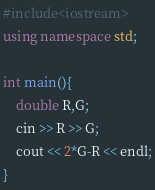Convert code to text. <code><loc_0><loc_0><loc_500><loc_500><_C++_>#include<iostream>
using namespace std;

int main(){
	double R,G;
	cin >> R >> G;
	cout << 2*G-R << endl;
}</code> 